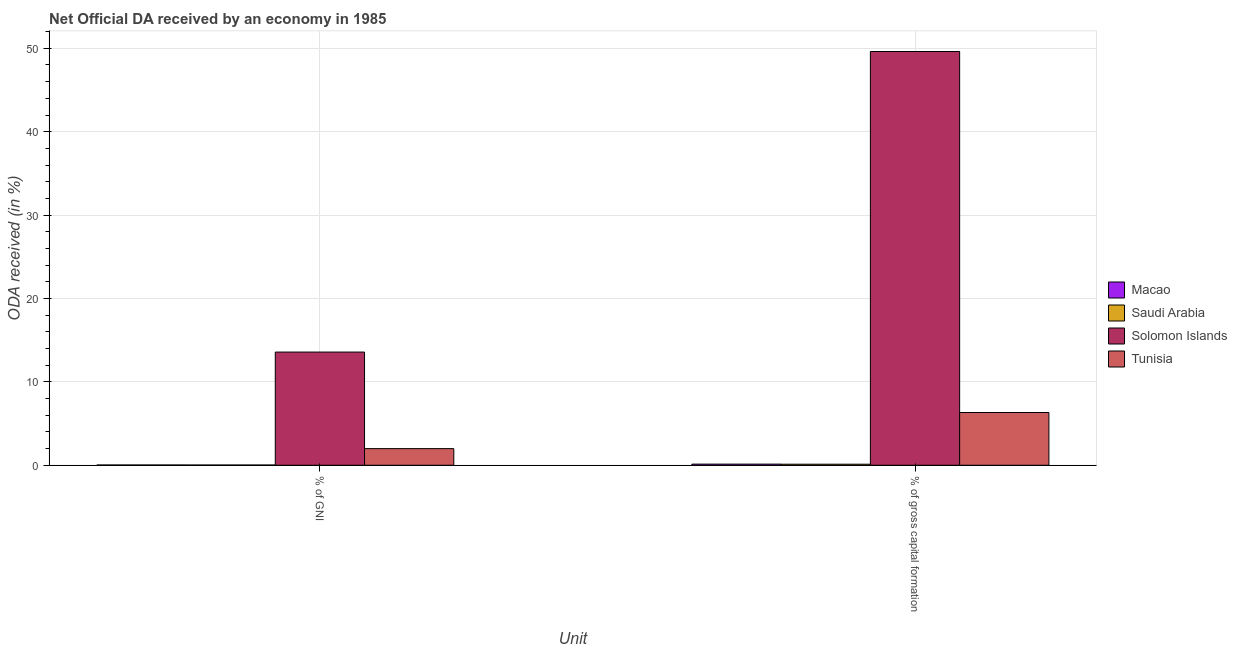How many groups of bars are there?
Provide a short and direct response. 2. Are the number of bars on each tick of the X-axis equal?
Provide a short and direct response. Yes. How many bars are there on the 1st tick from the left?
Provide a succinct answer. 4. How many bars are there on the 1st tick from the right?
Your answer should be compact. 4. What is the label of the 1st group of bars from the left?
Offer a terse response. % of GNI. What is the oda received as percentage of gross capital formation in Tunisia?
Give a very brief answer. 6.32. Across all countries, what is the maximum oda received as percentage of gni?
Offer a terse response. 13.57. Across all countries, what is the minimum oda received as percentage of gni?
Your response must be concise. 0.02. In which country was the oda received as percentage of gni maximum?
Give a very brief answer. Solomon Islands. In which country was the oda received as percentage of gni minimum?
Offer a very short reply. Saudi Arabia. What is the total oda received as percentage of gni in the graph?
Ensure brevity in your answer.  15.62. What is the difference between the oda received as percentage of gross capital formation in Macao and that in Solomon Islands?
Offer a terse response. -49.48. What is the difference between the oda received as percentage of gross capital formation in Tunisia and the oda received as percentage of gni in Macao?
Offer a terse response. 6.29. What is the average oda received as percentage of gross capital formation per country?
Give a very brief answer. 14.05. What is the difference between the oda received as percentage of gni and oda received as percentage of gross capital formation in Macao?
Your answer should be very brief. -0.1. What is the ratio of the oda received as percentage of gross capital formation in Solomon Islands to that in Saudi Arabia?
Offer a terse response. 402.42. Is the oda received as percentage of gni in Solomon Islands less than that in Saudi Arabia?
Provide a short and direct response. No. What does the 3rd bar from the left in % of gross capital formation represents?
Your response must be concise. Solomon Islands. What does the 1st bar from the right in % of gross capital formation represents?
Ensure brevity in your answer.  Tunisia. How many bars are there?
Offer a very short reply. 8. Are the values on the major ticks of Y-axis written in scientific E-notation?
Offer a very short reply. No. Does the graph contain any zero values?
Offer a terse response. No. Does the graph contain grids?
Provide a short and direct response. Yes. Where does the legend appear in the graph?
Provide a succinct answer. Center right. How are the legend labels stacked?
Provide a succinct answer. Vertical. What is the title of the graph?
Provide a succinct answer. Net Official DA received by an economy in 1985. Does "Bolivia" appear as one of the legend labels in the graph?
Ensure brevity in your answer.  No. What is the label or title of the X-axis?
Keep it short and to the point. Unit. What is the label or title of the Y-axis?
Give a very brief answer. ODA received (in %). What is the ODA received (in %) in Macao in % of GNI?
Give a very brief answer. 0.03. What is the ODA received (in %) of Saudi Arabia in % of GNI?
Offer a terse response. 0.02. What is the ODA received (in %) in Solomon Islands in % of GNI?
Provide a succinct answer. 13.57. What is the ODA received (in %) of Tunisia in % of GNI?
Provide a short and direct response. 1.99. What is the ODA received (in %) of Macao in % of gross capital formation?
Give a very brief answer. 0.13. What is the ODA received (in %) of Saudi Arabia in % of gross capital formation?
Provide a short and direct response. 0.12. What is the ODA received (in %) of Solomon Islands in % of gross capital formation?
Offer a terse response. 49.61. What is the ODA received (in %) in Tunisia in % of gross capital formation?
Ensure brevity in your answer.  6.32. Across all Unit, what is the maximum ODA received (in %) of Macao?
Offer a terse response. 0.13. Across all Unit, what is the maximum ODA received (in %) in Saudi Arabia?
Provide a succinct answer. 0.12. Across all Unit, what is the maximum ODA received (in %) in Solomon Islands?
Provide a succinct answer. 49.61. Across all Unit, what is the maximum ODA received (in %) in Tunisia?
Give a very brief answer. 6.32. Across all Unit, what is the minimum ODA received (in %) of Macao?
Provide a succinct answer. 0.03. Across all Unit, what is the minimum ODA received (in %) in Saudi Arabia?
Your response must be concise. 0.02. Across all Unit, what is the minimum ODA received (in %) in Solomon Islands?
Your answer should be compact. 13.57. Across all Unit, what is the minimum ODA received (in %) of Tunisia?
Keep it short and to the point. 1.99. What is the total ODA received (in %) in Macao in the graph?
Give a very brief answer. 0.17. What is the total ODA received (in %) in Saudi Arabia in the graph?
Give a very brief answer. 0.15. What is the total ODA received (in %) of Solomon Islands in the graph?
Provide a short and direct response. 63.18. What is the total ODA received (in %) in Tunisia in the graph?
Ensure brevity in your answer.  8.31. What is the difference between the ODA received (in %) of Macao in % of GNI and that in % of gross capital formation?
Provide a succinct answer. -0.1. What is the difference between the ODA received (in %) in Saudi Arabia in % of GNI and that in % of gross capital formation?
Provide a succinct answer. -0.1. What is the difference between the ODA received (in %) of Solomon Islands in % of GNI and that in % of gross capital formation?
Your answer should be compact. -36.04. What is the difference between the ODA received (in %) of Tunisia in % of GNI and that in % of gross capital formation?
Keep it short and to the point. -4.33. What is the difference between the ODA received (in %) in Macao in % of GNI and the ODA received (in %) in Saudi Arabia in % of gross capital formation?
Provide a succinct answer. -0.09. What is the difference between the ODA received (in %) of Macao in % of GNI and the ODA received (in %) of Solomon Islands in % of gross capital formation?
Make the answer very short. -49.58. What is the difference between the ODA received (in %) in Macao in % of GNI and the ODA received (in %) in Tunisia in % of gross capital formation?
Your response must be concise. -6.29. What is the difference between the ODA received (in %) of Saudi Arabia in % of GNI and the ODA received (in %) of Solomon Islands in % of gross capital formation?
Your answer should be compact. -49.59. What is the difference between the ODA received (in %) in Saudi Arabia in % of GNI and the ODA received (in %) in Tunisia in % of gross capital formation?
Your response must be concise. -6.3. What is the difference between the ODA received (in %) in Solomon Islands in % of GNI and the ODA received (in %) in Tunisia in % of gross capital formation?
Your answer should be very brief. 7.25. What is the average ODA received (in %) of Macao per Unit?
Provide a succinct answer. 0.08. What is the average ODA received (in %) of Saudi Arabia per Unit?
Offer a terse response. 0.07. What is the average ODA received (in %) of Solomon Islands per Unit?
Offer a very short reply. 31.59. What is the average ODA received (in %) of Tunisia per Unit?
Offer a terse response. 4.16. What is the difference between the ODA received (in %) of Macao and ODA received (in %) of Saudi Arabia in % of GNI?
Your response must be concise. 0.01. What is the difference between the ODA received (in %) of Macao and ODA received (in %) of Solomon Islands in % of GNI?
Ensure brevity in your answer.  -13.54. What is the difference between the ODA received (in %) of Macao and ODA received (in %) of Tunisia in % of GNI?
Your response must be concise. -1.96. What is the difference between the ODA received (in %) in Saudi Arabia and ODA received (in %) in Solomon Islands in % of GNI?
Your answer should be very brief. -13.55. What is the difference between the ODA received (in %) in Saudi Arabia and ODA received (in %) in Tunisia in % of GNI?
Make the answer very short. -1.97. What is the difference between the ODA received (in %) of Solomon Islands and ODA received (in %) of Tunisia in % of GNI?
Your response must be concise. 11.58. What is the difference between the ODA received (in %) in Macao and ODA received (in %) in Saudi Arabia in % of gross capital formation?
Ensure brevity in your answer.  0.01. What is the difference between the ODA received (in %) in Macao and ODA received (in %) in Solomon Islands in % of gross capital formation?
Offer a terse response. -49.48. What is the difference between the ODA received (in %) of Macao and ODA received (in %) of Tunisia in % of gross capital formation?
Make the answer very short. -6.19. What is the difference between the ODA received (in %) of Saudi Arabia and ODA received (in %) of Solomon Islands in % of gross capital formation?
Offer a terse response. -49.49. What is the difference between the ODA received (in %) of Saudi Arabia and ODA received (in %) of Tunisia in % of gross capital formation?
Your answer should be very brief. -6.2. What is the difference between the ODA received (in %) in Solomon Islands and ODA received (in %) in Tunisia in % of gross capital formation?
Offer a very short reply. 43.29. What is the ratio of the ODA received (in %) in Macao in % of GNI to that in % of gross capital formation?
Make the answer very short. 0.23. What is the ratio of the ODA received (in %) of Saudi Arabia in % of GNI to that in % of gross capital formation?
Your response must be concise. 0.19. What is the ratio of the ODA received (in %) of Solomon Islands in % of GNI to that in % of gross capital formation?
Your answer should be compact. 0.27. What is the ratio of the ODA received (in %) in Tunisia in % of GNI to that in % of gross capital formation?
Your answer should be compact. 0.31. What is the difference between the highest and the second highest ODA received (in %) in Macao?
Give a very brief answer. 0.1. What is the difference between the highest and the second highest ODA received (in %) in Saudi Arabia?
Provide a short and direct response. 0.1. What is the difference between the highest and the second highest ODA received (in %) in Solomon Islands?
Give a very brief answer. 36.04. What is the difference between the highest and the second highest ODA received (in %) in Tunisia?
Provide a succinct answer. 4.33. What is the difference between the highest and the lowest ODA received (in %) in Macao?
Offer a very short reply. 0.1. What is the difference between the highest and the lowest ODA received (in %) in Saudi Arabia?
Provide a succinct answer. 0.1. What is the difference between the highest and the lowest ODA received (in %) in Solomon Islands?
Give a very brief answer. 36.04. What is the difference between the highest and the lowest ODA received (in %) in Tunisia?
Keep it short and to the point. 4.33. 